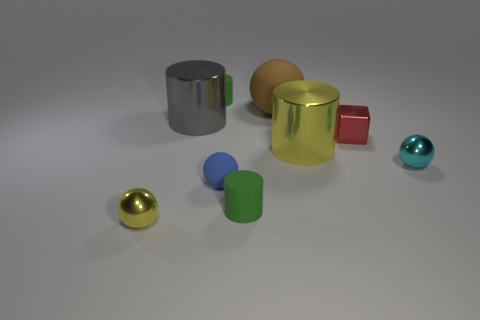Subtract all yellow cylinders. How many cylinders are left? 3 Subtract all brown balls. How many balls are left? 3 Subtract all yellow cubes. How many green cylinders are left? 2 Subtract 1 balls. How many balls are left? 3 Subtract all purple spheres. Subtract all green cylinders. How many spheres are left? 4 Add 7 big brown rubber spheres. How many big brown rubber spheres are left? 8 Add 8 big gray shiny things. How many big gray shiny things exist? 9 Subtract 1 red cubes. How many objects are left? 8 Subtract all spheres. How many objects are left? 5 Subtract all tiny gray rubber cylinders. Subtract all yellow balls. How many objects are left? 8 